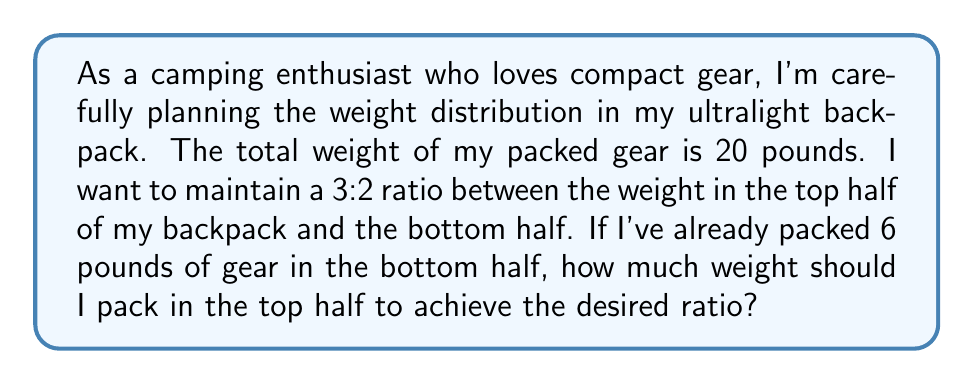Provide a solution to this math problem. Let's approach this step-by-step:

1) First, let's define our ratio. We want a 3:2 ratio between the top and bottom halves of the backpack.
   This means: $\frac{\text{Top weight}}{\text{Bottom weight}} = \frac{3}{2}$

2) We know the bottom weight is 6 pounds. Let's call the top weight $x$.
   So, we can write: $\frac{x}{6} = \frac{3}{2}$

3) To solve this, we can cross-multiply:
   $2x = 3 \cdot 6$

4) Simplify the right side:
   $2x = 18$

5) Divide both sides by 2:
   $x = 9$

6) Therefore, we need to pack 9 pounds in the top half of the backpack.

7) Let's verify the ratio:
   $\frac{\text{Top weight}}{\text{Bottom weight}} = \frac{9}{6} = \frac{3}{2}$

8) We can also check that the total weight is correct:
   Top weight + Bottom weight = 9 + 6 = 15 pounds

This is indeed the correct distribution, as it maintains the 3:2 ratio and keeps the total weight under the 20-pound limit.
Answer: 9 pounds 